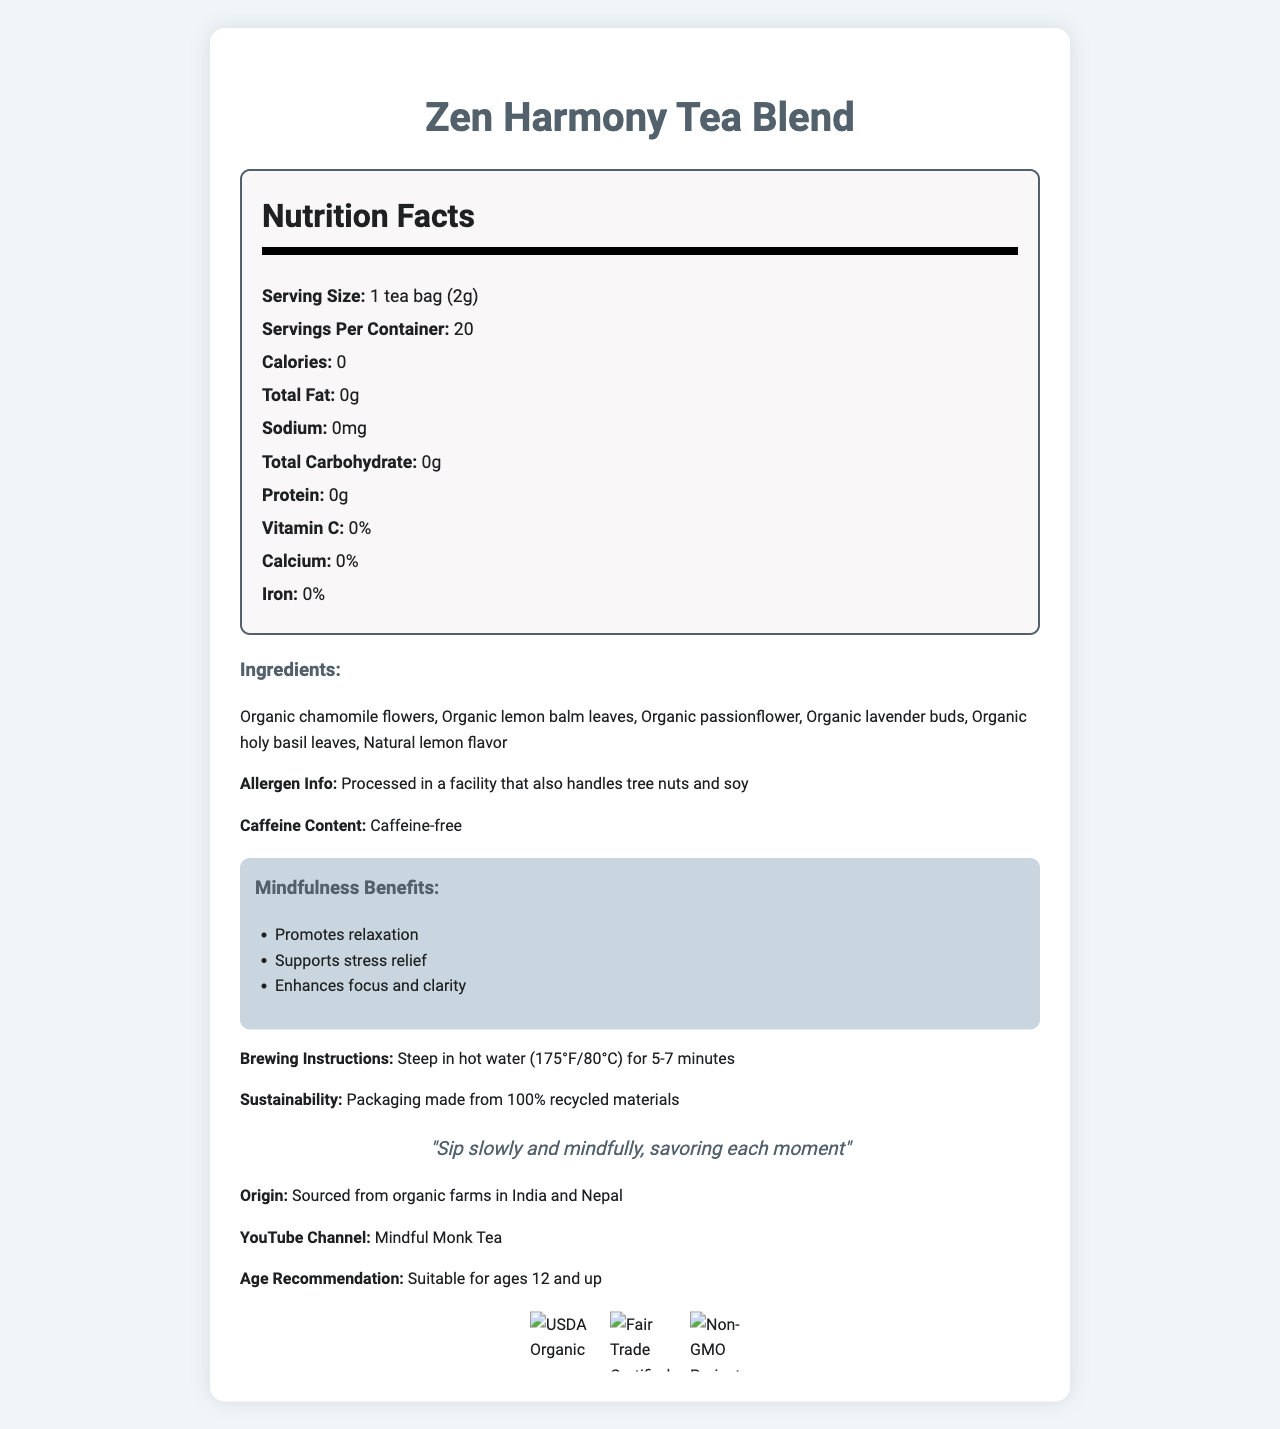what is the serving size? The serving size is listed as "1 tea bag (2g)" under the Nutrition Facts section.
Answer: 1 tea bag (2g) how many servings are there per container? The document states there are 20 servings per container.
Answer: 20 are there any calories in this tea blend? The label indicates that there are 0 calories per serving.
Answer: No is this tea caffeine-free? The document mentions that the tea is "Caffeine-free" under the ingredients section.
Answer: Yes what ingredients are included in this tea blend? The ingredients are listed in the ingredients section of the label.
Answer: Organic chamomile flowers, Organic lemon balm leaves, Organic passionflower, Organic lavender buds, Organic holy basil leaves, Natural lemon flavor does this product have any allergens? The allergen information states that the product is processed in a facility that handles tree nuts and soy.
Answer: Yes, processed in a facility that also handles tree nuts and soy which benefit is NOT mentioned as a mindfulness benefit of this tea blend? A. Promotes relaxation B. Supports stress relief C. Aids digestion D. Enhances focus and clarity The listed benefits are "Promotes relaxation," "Supports stress relief," and "Enhances focus and clarity." "Aids digestion" is not mentioned.
Answer: C. Aids digestion how long should you steep this tea blend in hot water? The brewing instructions state to steep the tea in hot water (175°F/80°C) for 5-7 minutes.
Answer: 5-7 minutes what is the origin of the ingredients used in this tea blend? The origin section mentions that the ingredients are sourced from organic farms in India and Nepal.
Answer: Sourced from organic farms in India and Nepal which certification is NOT listed on this label? A. USDA Organic B. Fair Trade Certified C. Non-GMO Project Verified D. Rainforest Alliance Certified The certifications listed are USDA Organic, Fair Trade Certified, and Non-GMO Project Verified. Rainforest Alliance Certified is not mentioned.
Answer: D. Rainforest Alliance Certified is this tea suitable for children? The age recommendation indicates that the tea is suitable for ages 12 and up.
Answer: Yes, for ages 12 and up describe the main idea of the document. The label highlights that the tea blend contains no calories, fat, sodium, carbohydrates, or protein, and it is made from organic ingredients. It promotes relaxation, supports stress relief, enhances focus and clarity, and is caffeine-free. The tea is suitable for ages 12 and up and comes with certifications like USDA Organic, Fair Trade Certified, and Non-GMO Project Verified.
Answer: The document provides detailed information about the Zen Harmony Tea Blend, including its nutritional facts, ingredients, allergen information, caffeine content, mindfulness benefits, brewing instructions, sustainability efforts, origin, recommended age, and certifications. what flavor is added to this tea blend for a natural touch? The ingredient list includes "Natural lemon flavor" as a component.
Answer: Natural lemon flavor what is the sustainability effort mentioned on the label? The label states that the packaging is made from 100% recycled materials.
Answer: Packaging made from 100% recycled materials where can you find more about this tea blend online? The label provides a YouTube channel name "Mindful Monk Tea" for more information.
Answer: YouTube Channel: Mindful Monk Tea what is the source of Vitamin C, calcium, or iron in this tea blend? The label lists 0% for Vitamin C, calcium, and iron, and does not mention any source of these nutrients in the ingredients.
Answer: Not enough information how should you sip this tea according to monk wisdom? The monk wisdom section advises to "Sip slowly and mindfully, savoring each moment."
Answer: Sip slowly and mindfully, savoring each moment 